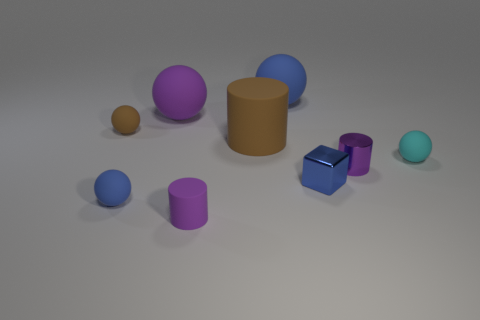What colors are represented in the objects shown? The objects display a variety of colors, including blue, purple, tan, cyan, and metallic shades.  Is there any pattern to the arrangement of these objects? The arrangement of the objects does not demonstrate a clear pattern. They are dispersed seemingly at random across the surface. 